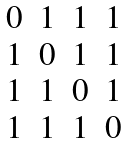Convert formula to latex. <formula><loc_0><loc_0><loc_500><loc_500>\begin{matrix} 0 & 1 & 1 & 1 \\ 1 & 0 & 1 & 1 \\ 1 & 1 & 0 & 1 \\ 1 & 1 & 1 & 0 \\ \end{matrix}</formula> 